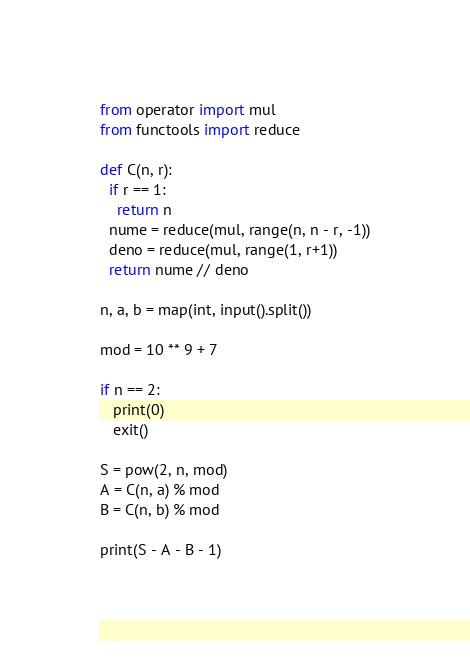<code> <loc_0><loc_0><loc_500><loc_500><_Python_>from operator import mul
from functools import reduce

def C(n, r):
  if r == 1:
    return n
  nume = reduce(mul, range(n, n - r, -1))
  deno = reduce(mul, range(1, r+1))
  return nume // deno

n, a, b = map(int, input().split())

mod = 10 ** 9 + 7

if n == 2:
   print(0)
   exit()
                
S = pow(2, n, mod)
A = C(n, a) % mod
B = C(n, b) % mod

print(S - A - B - 1)</code> 